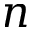<formula> <loc_0><loc_0><loc_500><loc_500>n</formula> 